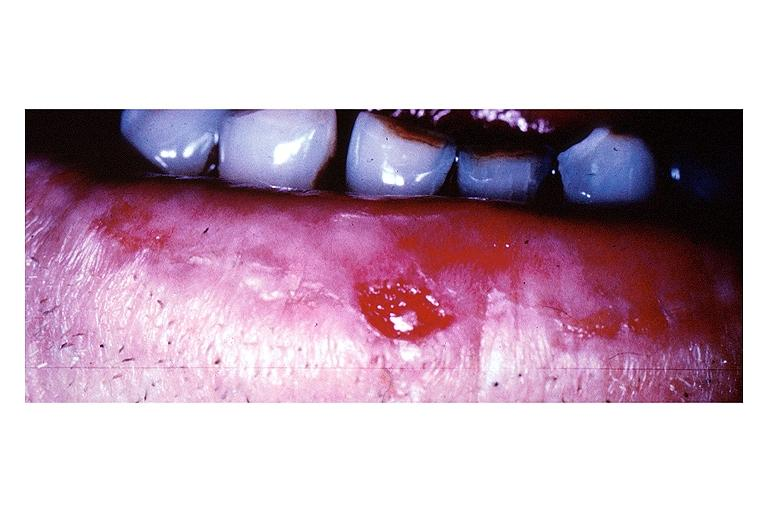does this image show squamous cell carcinoma?
Answer the question using a single word or phrase. Yes 